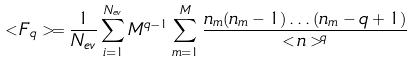<formula> <loc_0><loc_0><loc_500><loc_500>< F _ { q } > = \frac { 1 } { N _ { e v } } \sum _ { i = 1 } ^ { N _ { e v } } M ^ { q - 1 } \sum _ { m = 1 } ^ { M } \frac { n _ { m } ( n _ { m } - 1 ) \dots ( n _ { m } - q + 1 ) } { < n > ^ { q } }</formula> 